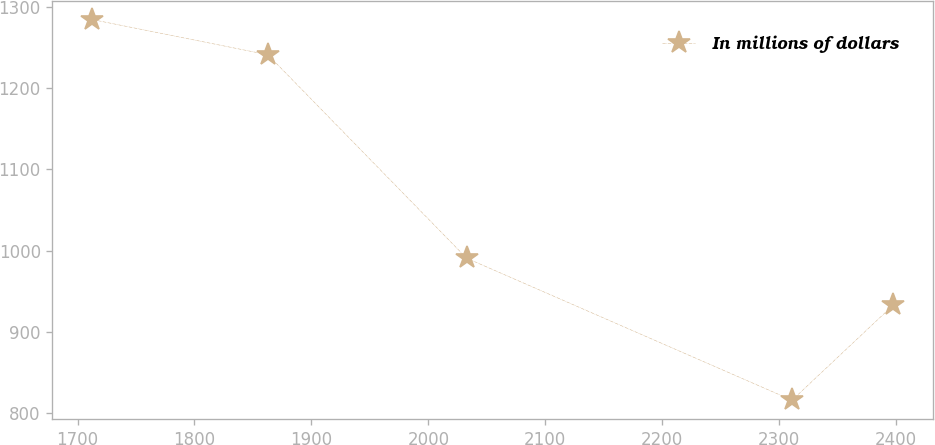<chart> <loc_0><loc_0><loc_500><loc_500><line_chart><ecel><fcel>In millions of dollars<nl><fcel>1712.79<fcel>1284.45<nl><fcel>1862.81<fcel>1241.16<nl><fcel>2032.73<fcel>990.77<nl><fcel>2311.01<fcel>815.92<nl><fcel>2397.55<fcel>933.06<nl></chart> 